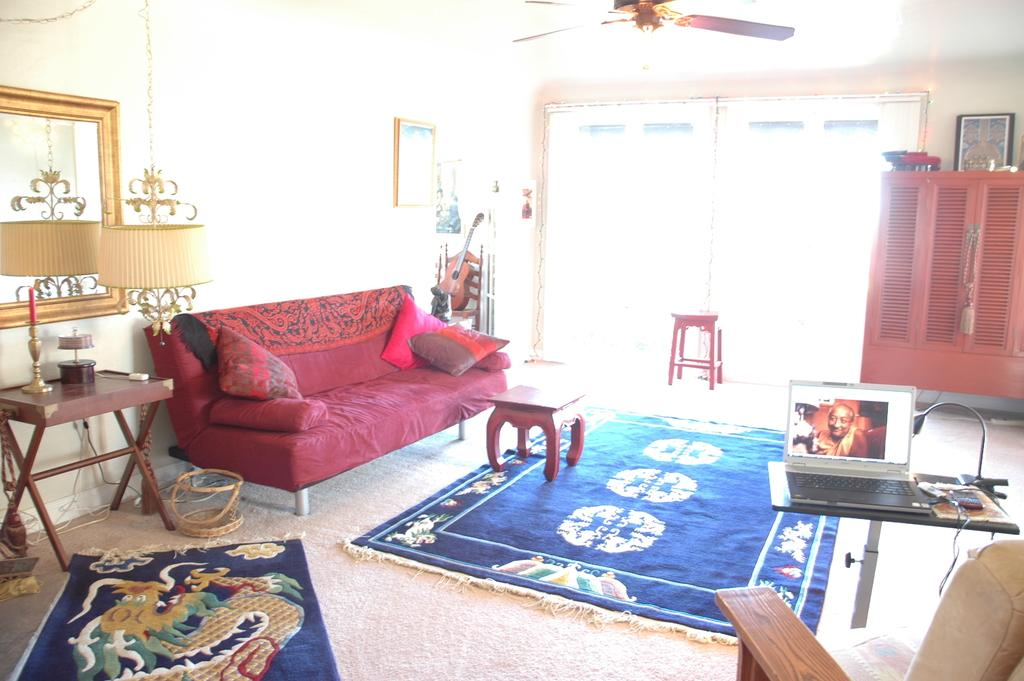What type of furniture is present in the living room? There is a sofa, a table, and a cupboard in the living room. What type of flooring is in the living room? There is a carpet in the living room. What type of seating is available in the living room? There are cushions in the living room. What type of musical instrument is in the living room? There is a guitar in the living room. What type of electronic device is in the living room? There is a laptop in the living room. What type of appliance is in the living room? There is a fan in the living room. What type of reflective surface is in the living room? There is a mirror in the living room. What type of lighting is in the living room? There are lamps in the living room. How many people are in the crowd in the living room? There is no crowd present in the living room; it is a room with various items and furniture. What shape is the earth in the living room? There is no representation of the earth in the living room. What type of geometric shape is the square in the living room? There is no square present in the living room. 